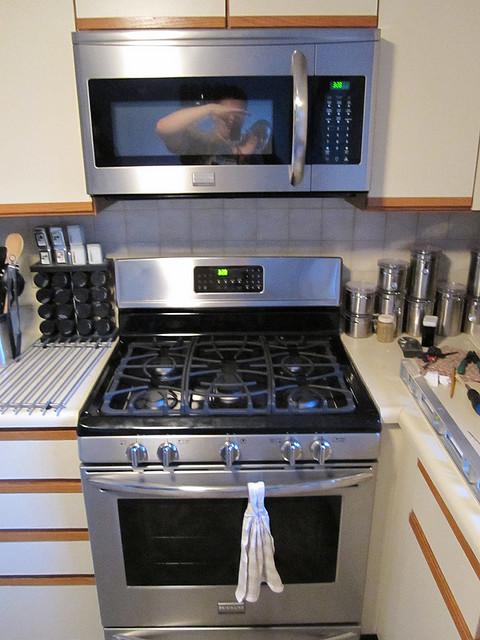Is the microwave open?
Concise answer only. No. How many shades of brown?
Quick response, please. 1. Is this an electric stove?
Concise answer only. No. How many people are reflected in the microwave window?
Be succinct. 1. 